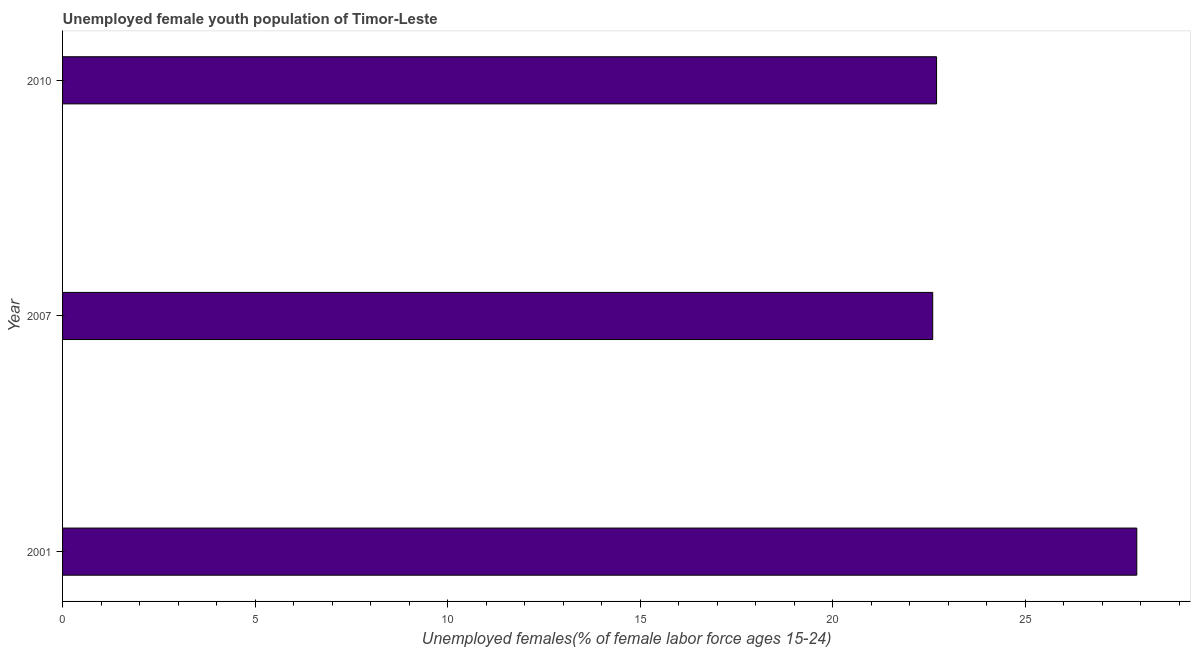What is the title of the graph?
Make the answer very short. Unemployed female youth population of Timor-Leste. What is the label or title of the X-axis?
Your answer should be very brief. Unemployed females(% of female labor force ages 15-24). What is the label or title of the Y-axis?
Ensure brevity in your answer.  Year. What is the unemployed female youth in 2010?
Make the answer very short. 22.7. Across all years, what is the maximum unemployed female youth?
Provide a succinct answer. 27.9. Across all years, what is the minimum unemployed female youth?
Your response must be concise. 22.6. What is the sum of the unemployed female youth?
Offer a very short reply. 73.2. What is the difference between the unemployed female youth in 2001 and 2007?
Make the answer very short. 5.3. What is the average unemployed female youth per year?
Keep it short and to the point. 24.4. What is the median unemployed female youth?
Ensure brevity in your answer.  22.7. Do a majority of the years between 2007 and 2010 (inclusive) have unemployed female youth greater than 24 %?
Your answer should be very brief. No. What is the ratio of the unemployed female youth in 2001 to that in 2010?
Your answer should be compact. 1.23. Is the difference between the unemployed female youth in 2001 and 2007 greater than the difference between any two years?
Offer a terse response. Yes. In how many years, is the unemployed female youth greater than the average unemployed female youth taken over all years?
Offer a very short reply. 1. Are all the bars in the graph horizontal?
Make the answer very short. Yes. What is the difference between two consecutive major ticks on the X-axis?
Your answer should be very brief. 5. Are the values on the major ticks of X-axis written in scientific E-notation?
Make the answer very short. No. What is the Unemployed females(% of female labor force ages 15-24) in 2001?
Offer a terse response. 27.9. What is the Unemployed females(% of female labor force ages 15-24) of 2007?
Your answer should be very brief. 22.6. What is the Unemployed females(% of female labor force ages 15-24) of 2010?
Offer a very short reply. 22.7. What is the difference between the Unemployed females(% of female labor force ages 15-24) in 2007 and 2010?
Your answer should be very brief. -0.1. What is the ratio of the Unemployed females(% of female labor force ages 15-24) in 2001 to that in 2007?
Your response must be concise. 1.24. What is the ratio of the Unemployed females(% of female labor force ages 15-24) in 2001 to that in 2010?
Offer a very short reply. 1.23. 